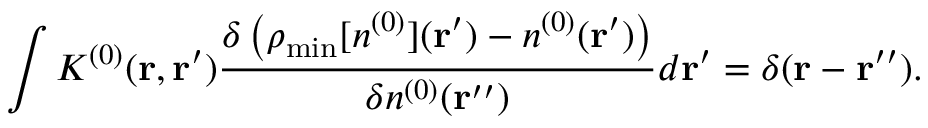<formula> <loc_0><loc_0><loc_500><loc_500>\int K ^ { ( 0 ) } ( { r , r ^ { \prime } } ) \frac { \delta \left ( \rho _ { \min } [ n ^ { ( 0 ) } ] ( { r ^ { \prime } } ) - n ^ { ( 0 ) } ( { r ^ { \prime } } ) \right ) } { { \delta n ^ { ( 0 ) } ( { r ^ { \prime \prime } } ) } } d { r ^ { \prime } } = \delta ( { r - r ^ { \prime \prime } } ) .</formula> 